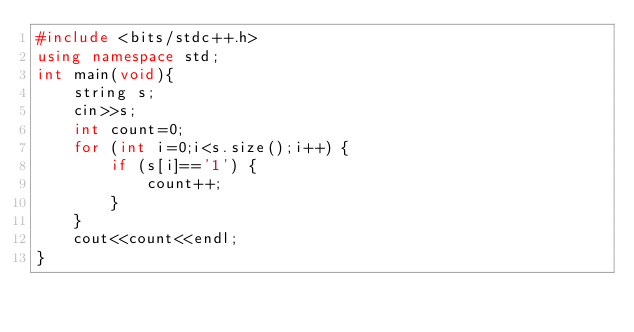Convert code to text. <code><loc_0><loc_0><loc_500><loc_500><_C++_>#include <bits/stdc++.h>
using namespace std;
int main(void){
    string s;
    cin>>s;
    int count=0;
    for (int i=0;i<s.size();i++) {
        if (s[i]=='1') {
            count++;
        }
    }
    cout<<count<<endl;
}</code> 